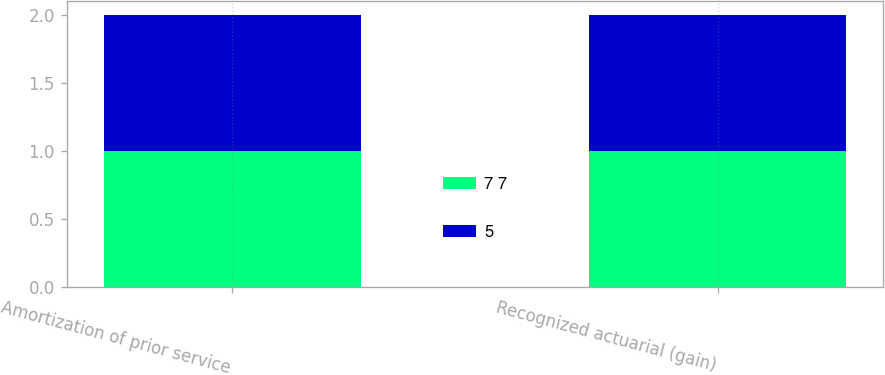<chart> <loc_0><loc_0><loc_500><loc_500><stacked_bar_chart><ecel><fcel>Amortization of prior service<fcel>Recognized actuarial (gain)<nl><fcel>7 7<fcel>1<fcel>1<nl><fcel>5<fcel>1<fcel>1<nl></chart> 